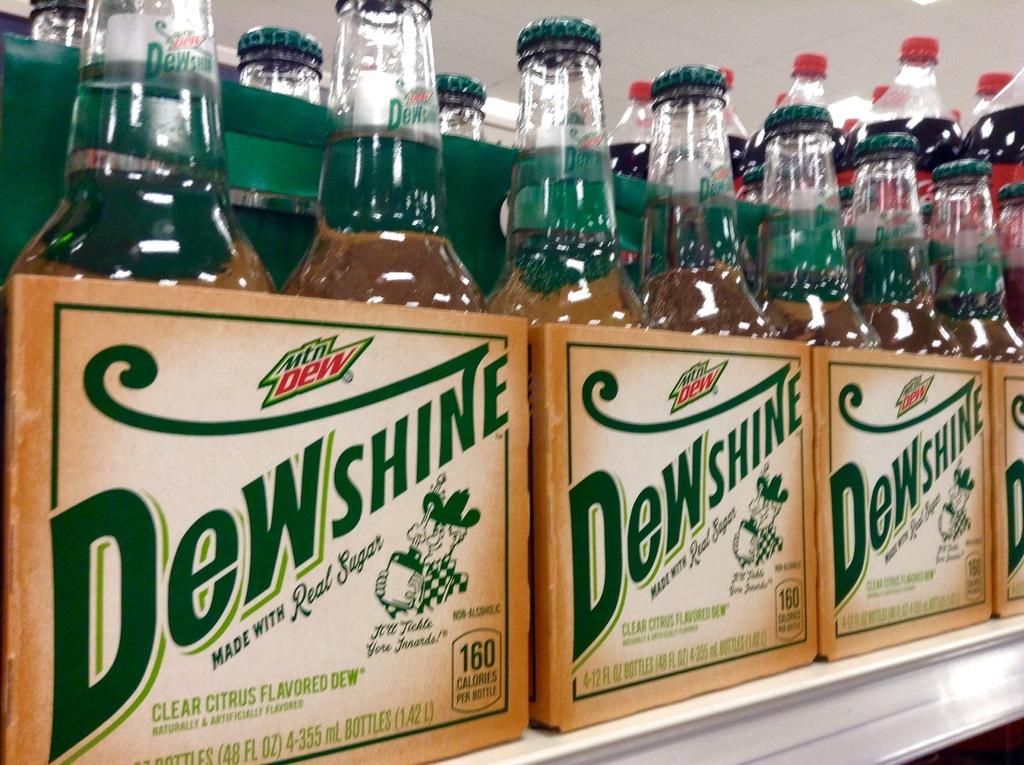What is the brand name?
Give a very brief answer. Dewshine. 